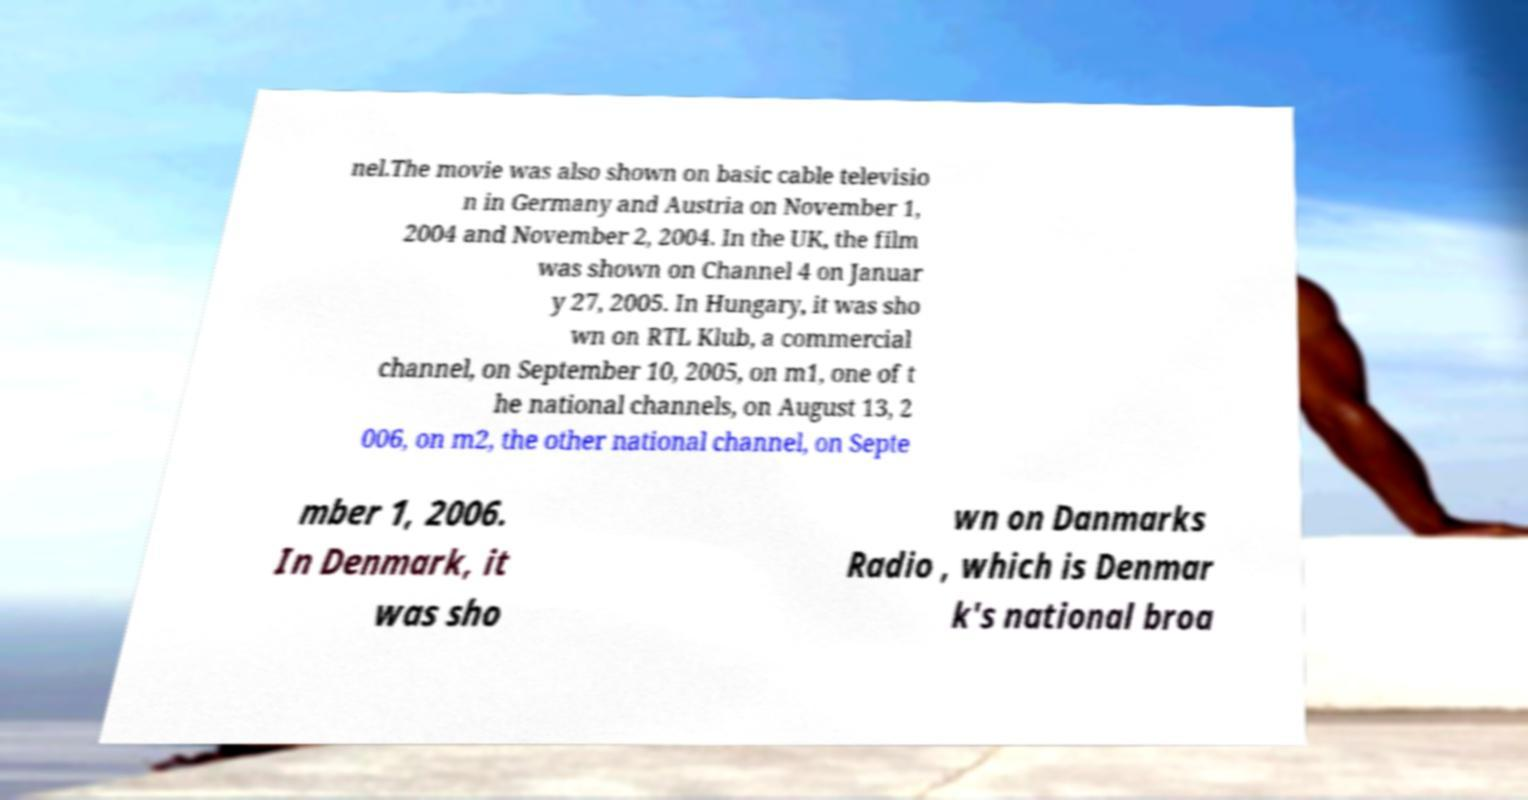What messages or text are displayed in this image? I need them in a readable, typed format. nel.The movie was also shown on basic cable televisio n in Germany and Austria on November 1, 2004 and November 2, 2004. In the UK, the film was shown on Channel 4 on Januar y 27, 2005. In Hungary, it was sho wn on RTL Klub, a commercial channel, on September 10, 2005, on m1, one of t he national channels, on August 13, 2 006, on m2, the other national channel, on Septe mber 1, 2006. In Denmark, it was sho wn on Danmarks Radio , which is Denmar k's national broa 